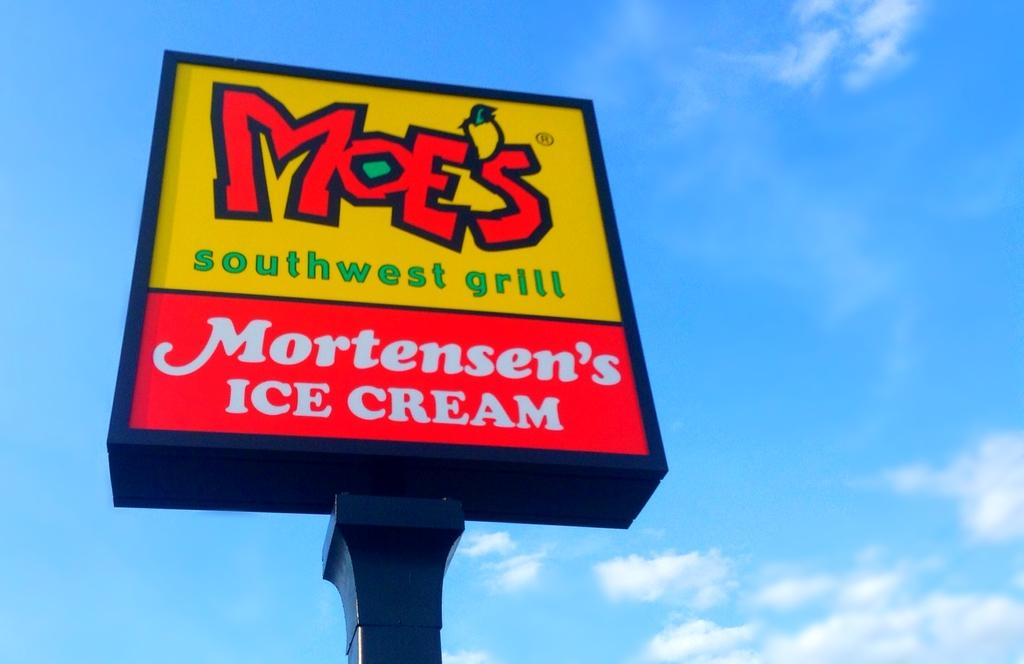<image>
Create a compact narrative representing the image presented. A Moes Southwest grill logo shares a sign with Mortensen's Ice Cream 